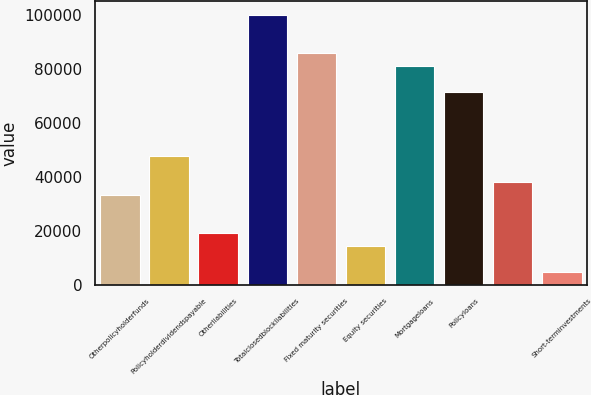Convert chart. <chart><loc_0><loc_0><loc_500><loc_500><bar_chart><fcel>Otherpolicyholderfunds<fcel>Policyholderdividendspayable<fcel>Otherliabilities<fcel>Totalclosedblockliabilities<fcel>Fixed maturity securities<fcel>Equity securities<fcel>Mortgageloans<fcel>Policyloans<fcel>Unnamed: 8<fcel>Short-terminvestments<nl><fcel>33360.9<fcel>47652<fcel>19069.8<fcel>100053<fcel>85761.6<fcel>14306.1<fcel>80997.9<fcel>71470.5<fcel>38124.6<fcel>4778.7<nl></chart> 